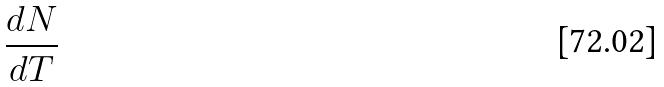Convert formula to latex. <formula><loc_0><loc_0><loc_500><loc_500>\frac { d N } { d T }</formula> 